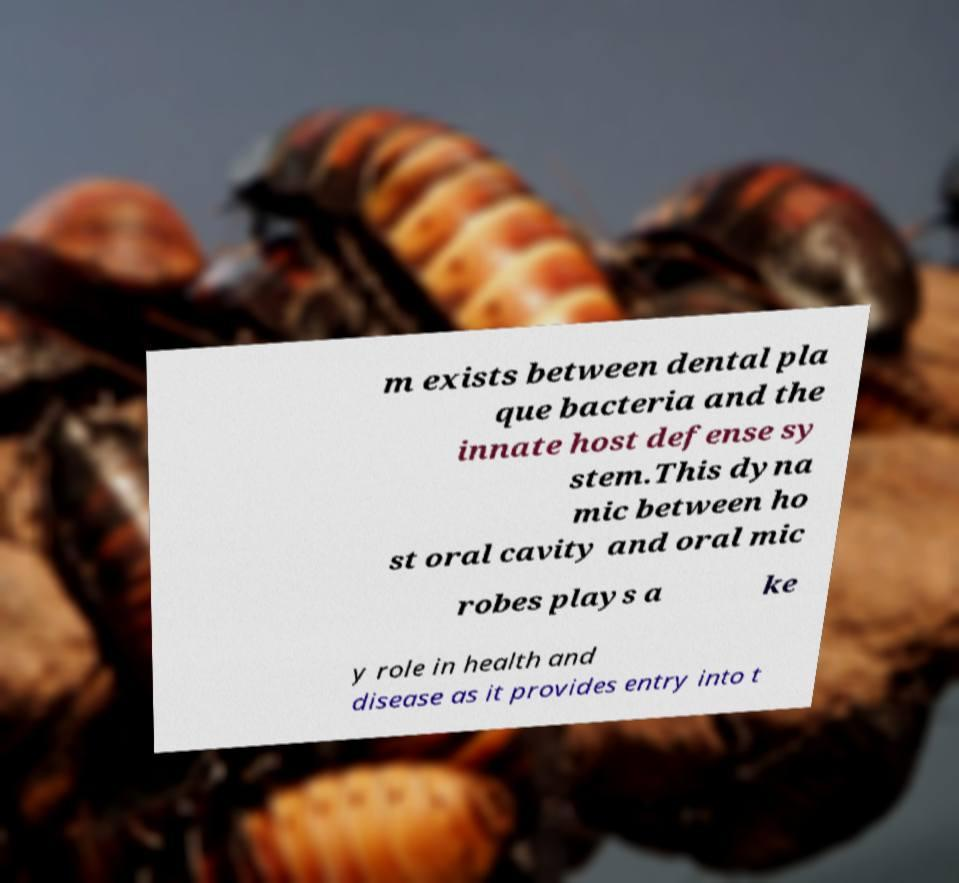What messages or text are displayed in this image? I need them in a readable, typed format. m exists between dental pla que bacteria and the innate host defense sy stem.This dyna mic between ho st oral cavity and oral mic robes plays a ke y role in health and disease as it provides entry into t 